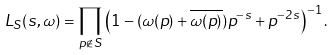Convert formula to latex. <formula><loc_0><loc_0><loc_500><loc_500>L _ { S } ( s , \omega ) = \prod _ { p \not \in S } \left ( 1 - ( \omega ( p ) + \overline { \omega ( p ) } ) p ^ { - s } + p ^ { - 2 s } \right ) ^ { - 1 } .</formula> 